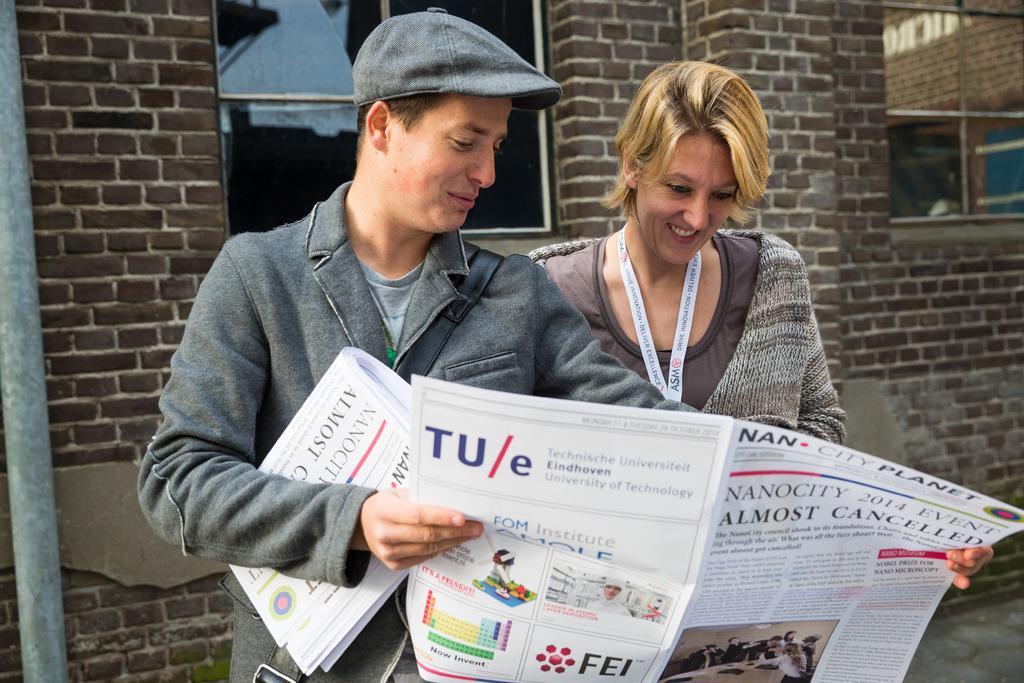Please provide a concise description of this image. Here in this picture we can see a man and a woman standing over a place and both of them are holding a newspaper and smiling and the man is wearing a coat and cap on him and behind them we can see a building with couple of windows present. 